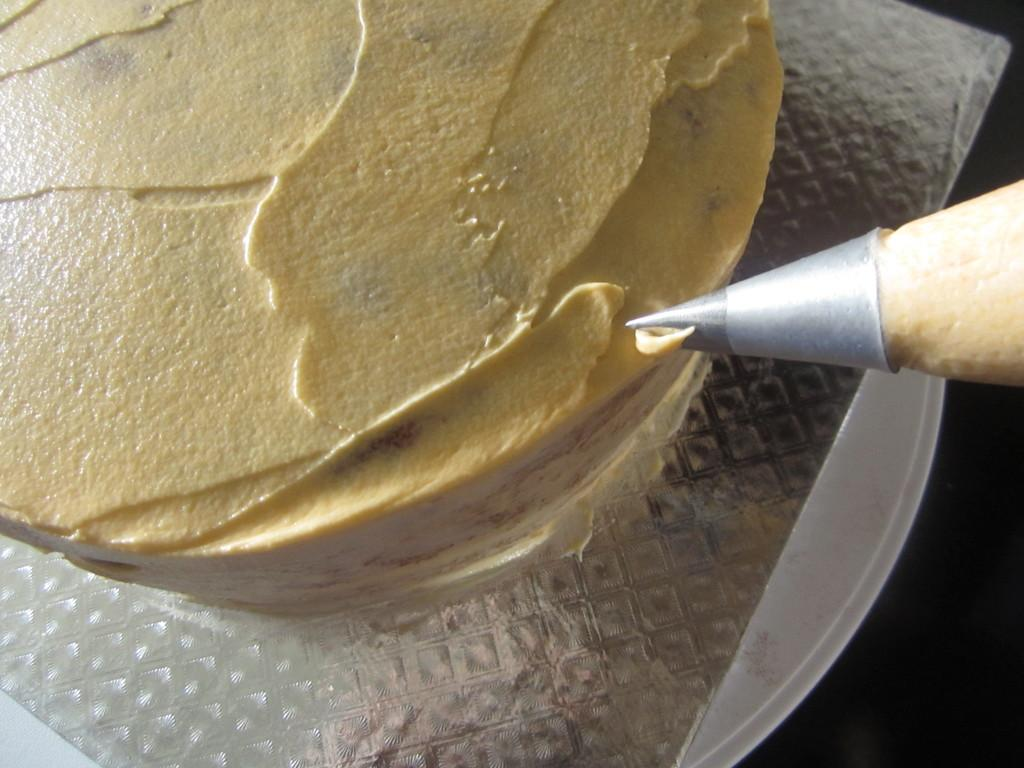What is the main subject of the image? The main subject of the image is a cake. What is the cone-shaped object in the image? There is an icing cone in the image. What material is present in the image? There is cardboard in the image. What might the cake be placed on in the image? There is a plate in the image. What type of music is the band playing in the background of the image? There is no band present in the image, so it's not possible to determine what type of music they might be playing. 